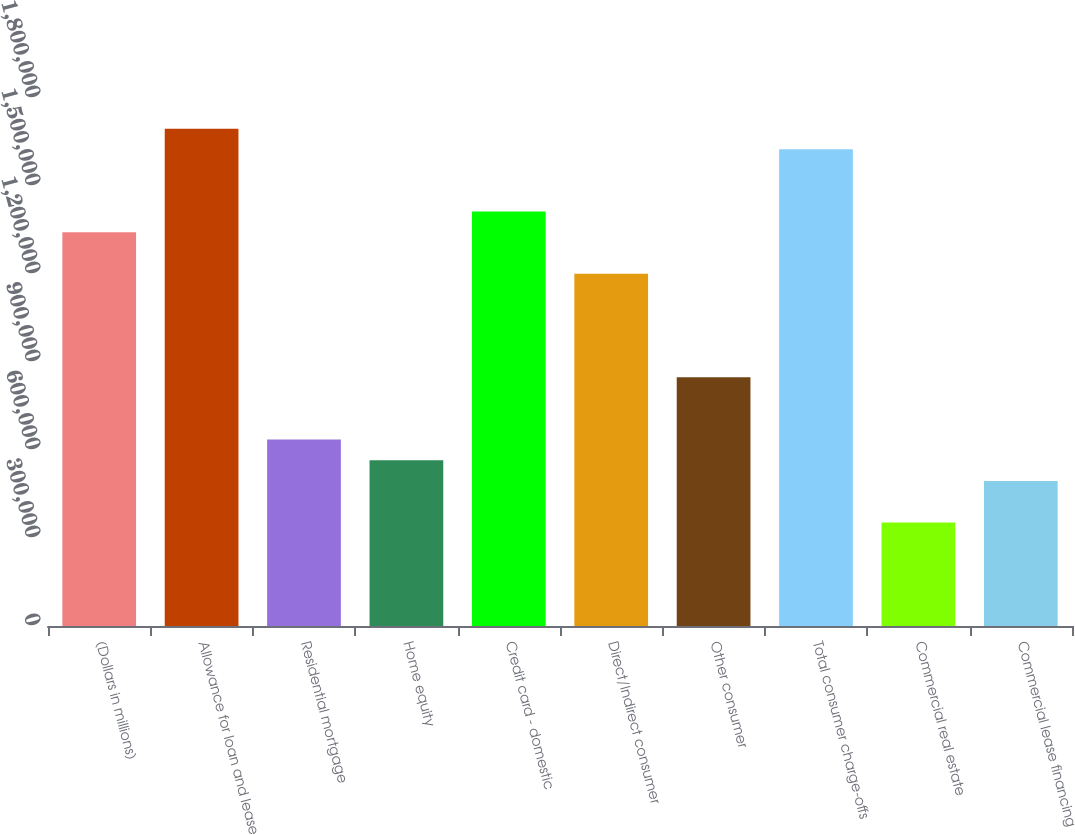<chart> <loc_0><loc_0><loc_500><loc_500><bar_chart><fcel>(Dollars in millions)<fcel>Allowance for loan and lease<fcel>Residential mortgage<fcel>Home equity<fcel>Credit card - domestic<fcel>Direct/Indirect consumer<fcel>Other consumer<fcel>Total consumer charge-offs<fcel>Commercial real estate<fcel>Commercial lease financing<nl><fcel>1.34233e+06<fcel>1.69558e+06<fcel>635841<fcel>565192<fcel>1.41298e+06<fcel>1.20103e+06<fcel>847788<fcel>1.62493e+06<fcel>353245<fcel>494543<nl></chart> 